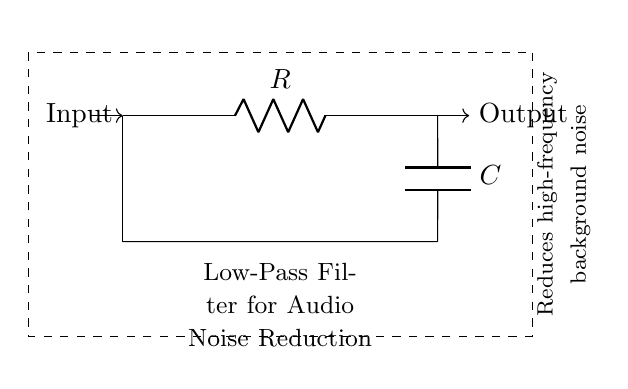What type of filter is represented by this circuit? This circuit is identified as a low-pass filter because it is designed to allow low-frequency signals to pass through while attenuating high-frequency signals. The components used, resistor and capacitor, are typically utilized in such configurations.
Answer: low-pass filter What is the function of the resistor in this circuit? The resistor in a low-pass filter serves to limit the current flow through the circuit and contributes to the time constant along with the capacitor. This establishes the cutoff frequency, which determines how much of the high-frequency signals will be attenuated.
Answer: limit current What is the role of the capacitor in this circuit? The capacitor in the low-pass filter allows low-frequency signals to pass through while blocking high-frequency signals. It charges and discharges based on the frequency of the input signal. A higher frequency signal charges and discharges more quickly, which results in attenuation.
Answer: attenuate high-frequency What is the output signal of this circuit? The output signal at point "Output" after filtering will be a reduced amplitude version of the input signal, predominantly composed of low-frequency components, with high-frequency noise filtered out. Therefore, it will have less background noise.
Answer: reduced amplitude of input How does the component arrangement affect the cutoff frequency of this low-pass filter? The cutoff frequency of a low-pass filter is determined by the values of the resistor and capacitor using the formula f_c = 1/(2πRC). Changes in either the resistor's resistance (R) or the capacitor's capacitance (C) will affect the frequency at which signals are attenuated, hence shifting the cutoff frequency.
Answer: affects cutoff frequency What does the dashed rectangle indicate in the circuit? The dashed rectangle surrounding the circuit highlights the specific circuit block functioning as a low-pass filter. It emphasizes the purpose of the components contained within, which is to specialize in reducing high-frequency noise from audio signals.
Answer: low-pass filter block 